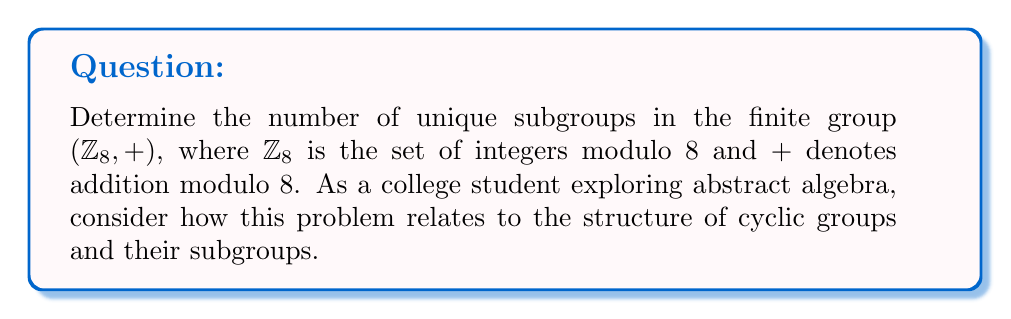Could you help me with this problem? Let's approach this step-by-step:

1) First, recall that $\mathbb{Z}_8 = \{0, 1, 2, 3, 4, 5, 6, 7\}$ under addition modulo 8.

2) $(\mathbb{Z}_8, +)$ is a cyclic group of order 8, generated by the element 1.

3) For a cyclic group of order $n$, the number of subgroups is equal to the number of divisors of $n$.

4) The divisors of 8 are 1, 2, 4, and 8.

5) Now, let's identify these subgroups:

   a) The subgroup of order 1: $\{0\}$
   b) The subgroup of order 2: $\{0, 4\}$
   c) The subgroup of order 4: $\{0, 2, 4, 6\}$
   d) The subgroup of order 8: $\{0, 1, 2, 3, 4, 5, 6, 7\}$ (the whole group)

6) We can verify that these are indeed all the subgroups:
   - $\langle 1 \rangle = \langle 3 \rangle = \langle 5 \rangle = \langle 7 \rangle = \mathbb{Z}_8$
   - $\langle 2 \rangle = \langle 6 \rangle = \{0, 2, 4, 6\}$
   - $\langle 4 \rangle = \{0, 4\}$

7) Therefore, there are 4 unique subgroups in $(\mathbb{Z}_8, +)$.
Answer: 4 